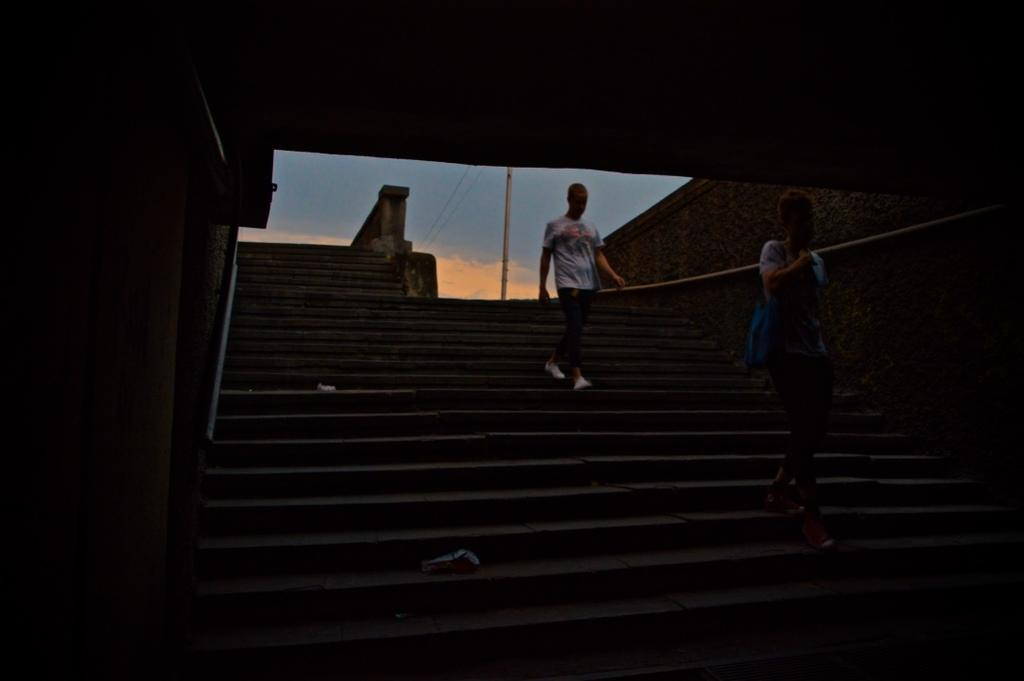How many people are in the image? There are two persons in the image. What are the persons wearing? The persons are wearing T-shirts. What are the persons carrying? The persons are carrying bags. What are the persons doing in the image? The persons are walking on stairs. What can be seen in the background of the image? There is a pole and the sky visible in the background of the image. How does the increase in temperature affect the whip in the image? There is no whip present in the image, so the increase in temperature does not affect anything in the image. What type of carriage can be seen in the image? There is no carriage present in the image. 